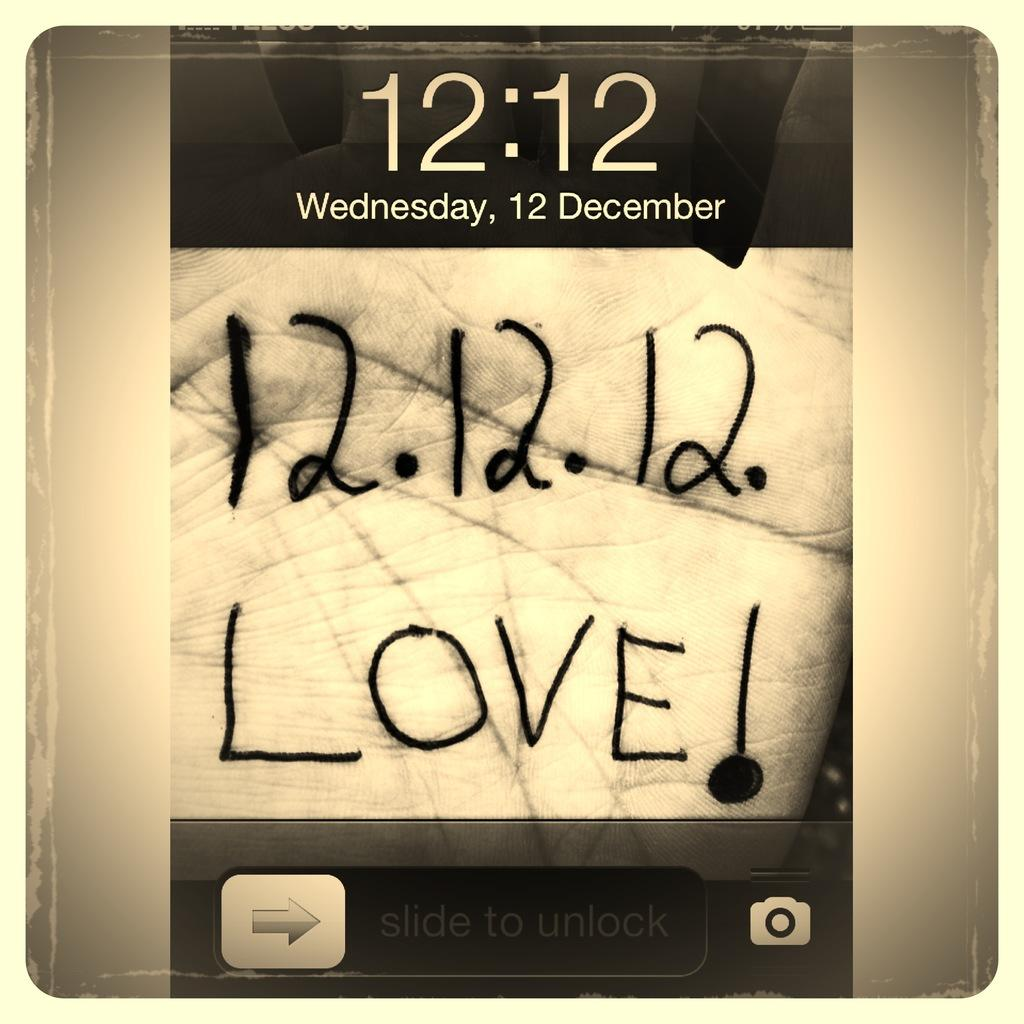<image>
Share a concise interpretation of the image provided. A phone screen shot of the date and time of Wednesday December 12 at 12:12. 